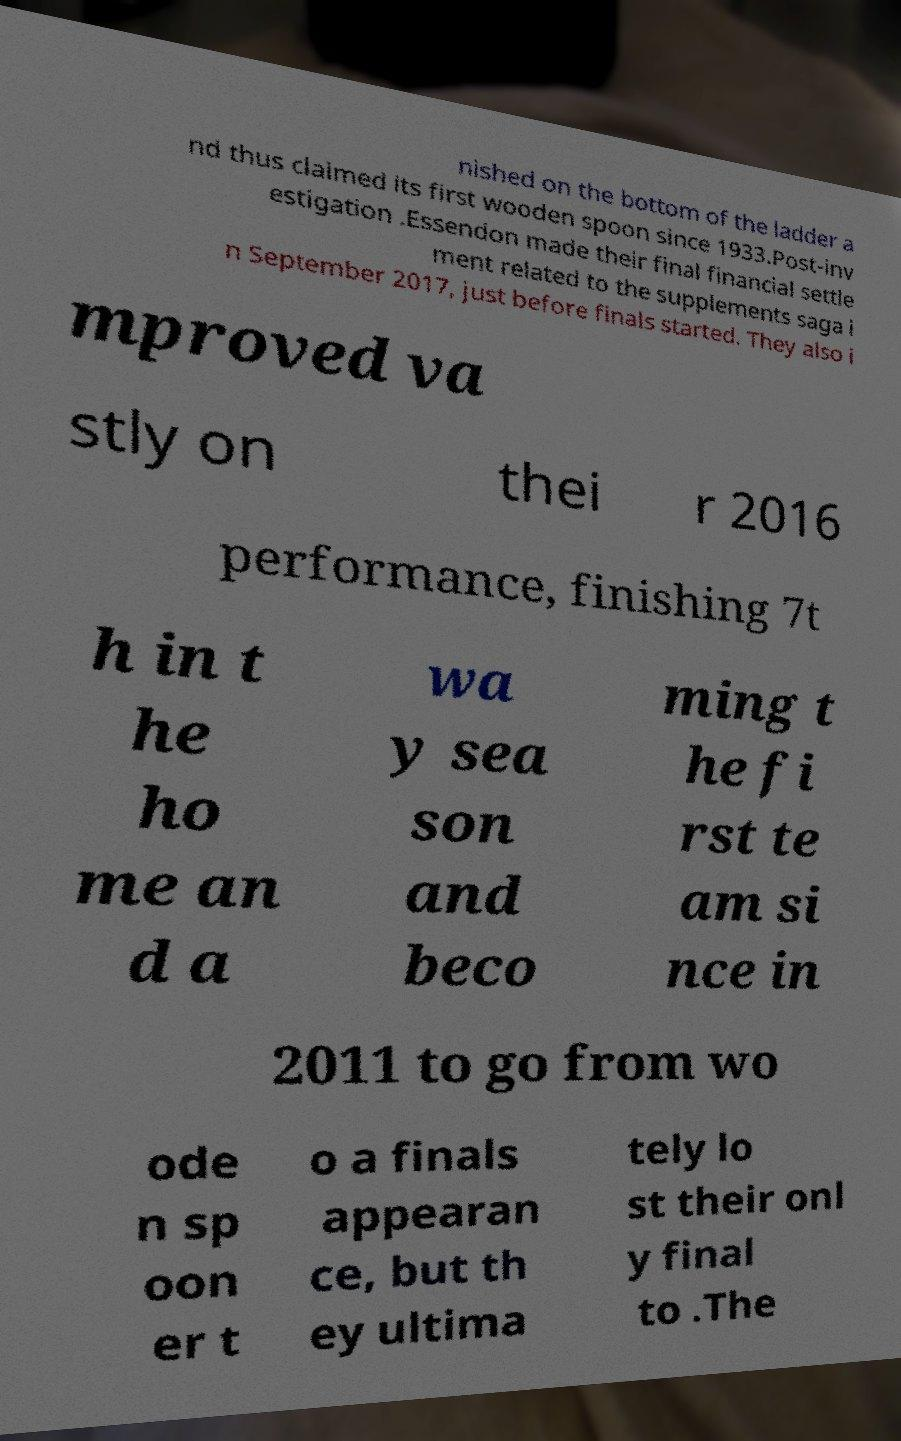There's text embedded in this image that I need extracted. Can you transcribe it verbatim? nished on the bottom of the ladder a nd thus claimed its first wooden spoon since 1933.Post-inv estigation .Essendon made their final financial settle ment related to the supplements saga i n September 2017, just before finals started. They also i mproved va stly on thei r 2016 performance, finishing 7t h in t he ho me an d a wa y sea son and beco ming t he fi rst te am si nce in 2011 to go from wo ode n sp oon er t o a finals appearan ce, but th ey ultima tely lo st their onl y final to .The 